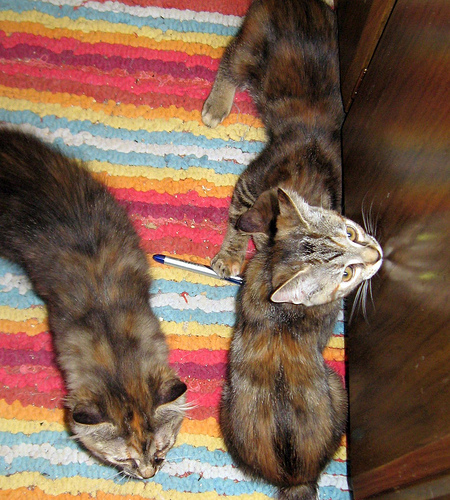<image>
Can you confirm if the cat is behind the sofa? Yes. From this viewpoint, the cat is positioned behind the sofa, with the sofa partially or fully occluding the cat. 